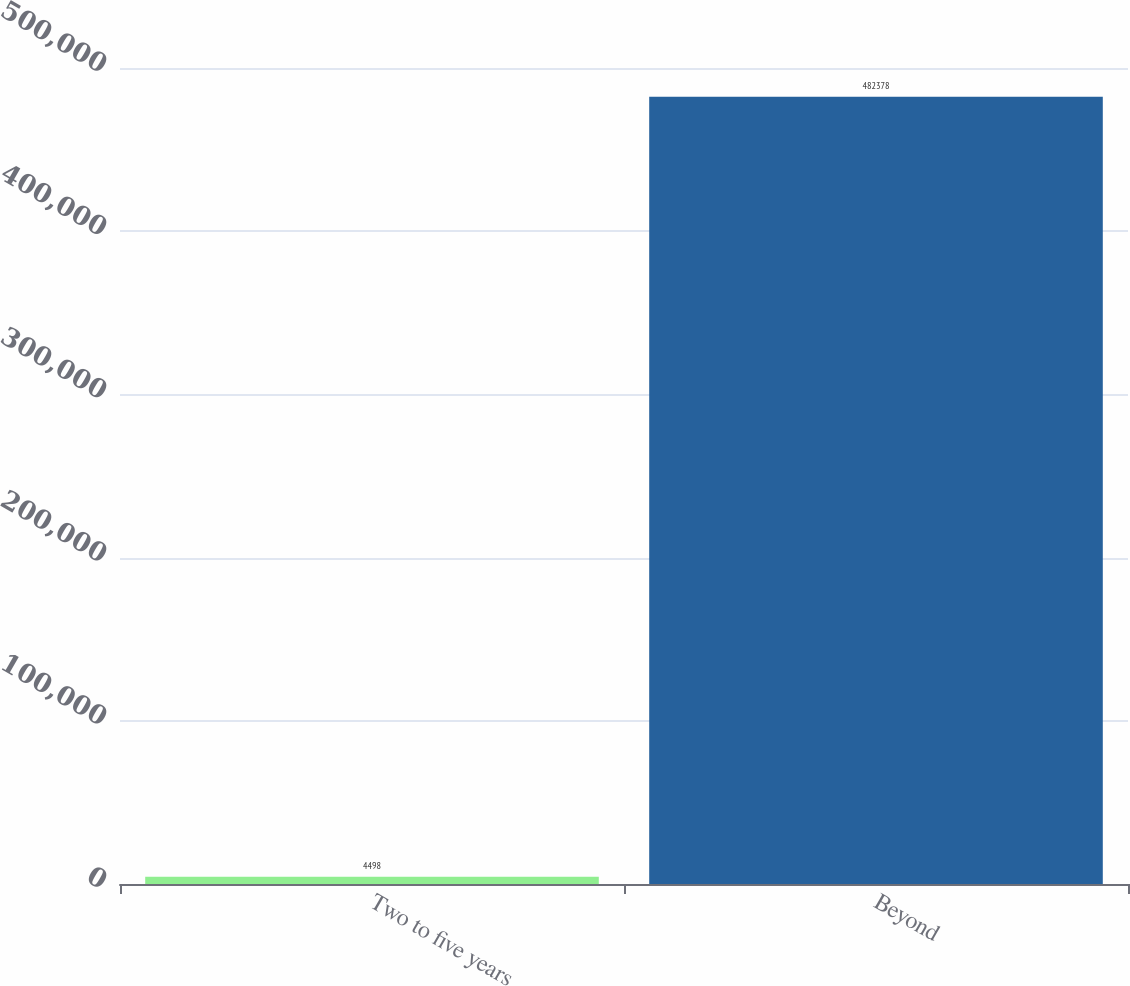<chart> <loc_0><loc_0><loc_500><loc_500><bar_chart><fcel>Two to five years<fcel>Beyond<nl><fcel>4498<fcel>482378<nl></chart> 